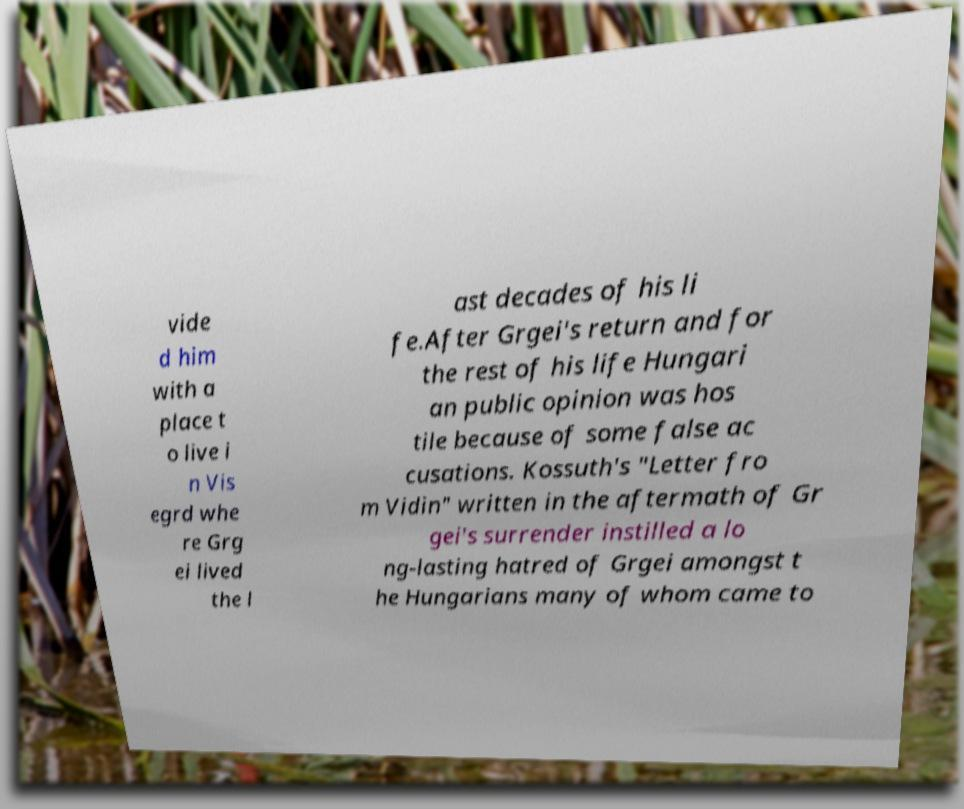There's text embedded in this image that I need extracted. Can you transcribe it verbatim? vide d him with a place t o live i n Vis egrd whe re Grg ei lived the l ast decades of his li fe.After Grgei's return and for the rest of his life Hungari an public opinion was hos tile because of some false ac cusations. Kossuth's "Letter fro m Vidin" written in the aftermath of Gr gei's surrender instilled a lo ng-lasting hatred of Grgei amongst t he Hungarians many of whom came to 